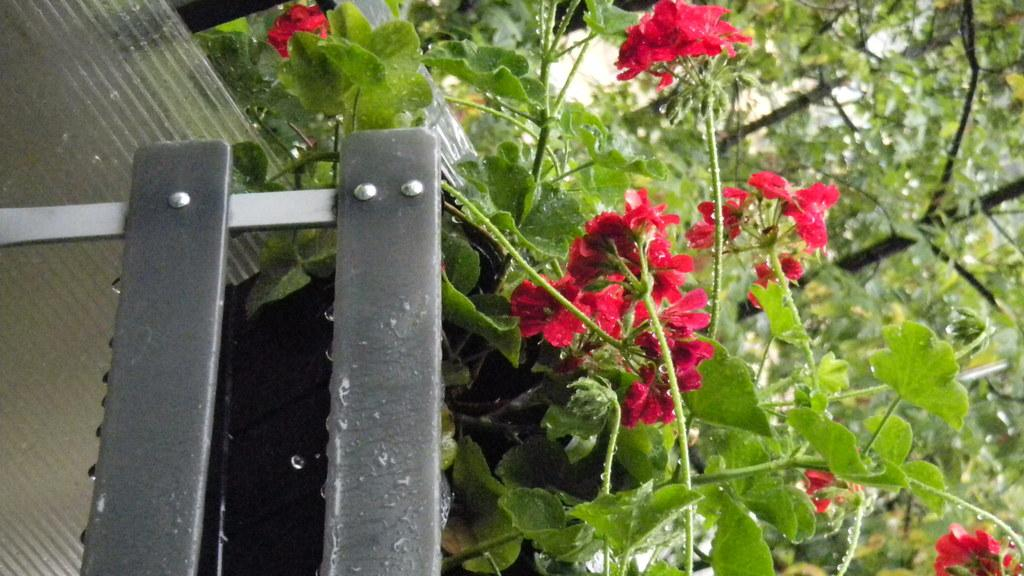What type of living organisms can be seen on the plant in the image? There are flowers on a plant in the image. Where is the plant located in relation to the fencing? The plant is beside a fencing in the image. What can be seen in the background of the image? Trees are visible in the background of the image. Who is the manager of the operation taking place in the image? There is no operation or manager present in the image; it features a plant with flowers beside a fencing. 